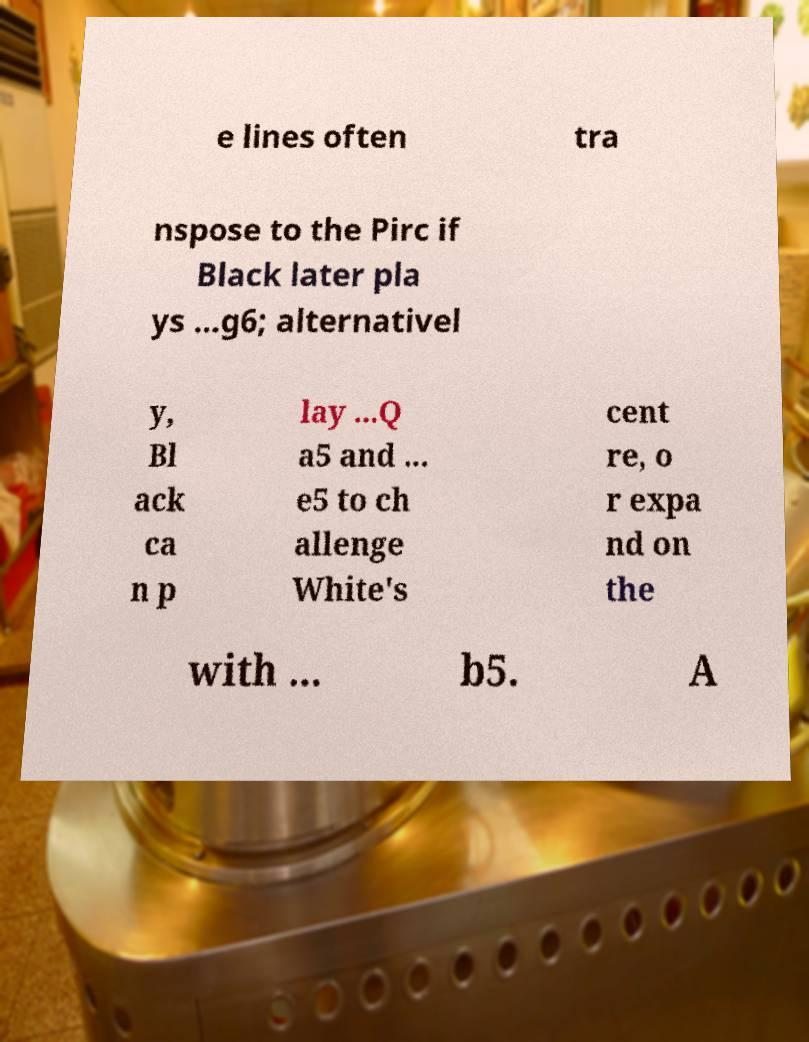There's text embedded in this image that I need extracted. Can you transcribe it verbatim? e lines often tra nspose to the Pirc if Black later pla ys ...g6; alternativel y, Bl ack ca n p lay ...Q a5 and ... e5 to ch allenge White's cent re, o r expa nd on the with ... b5. A 